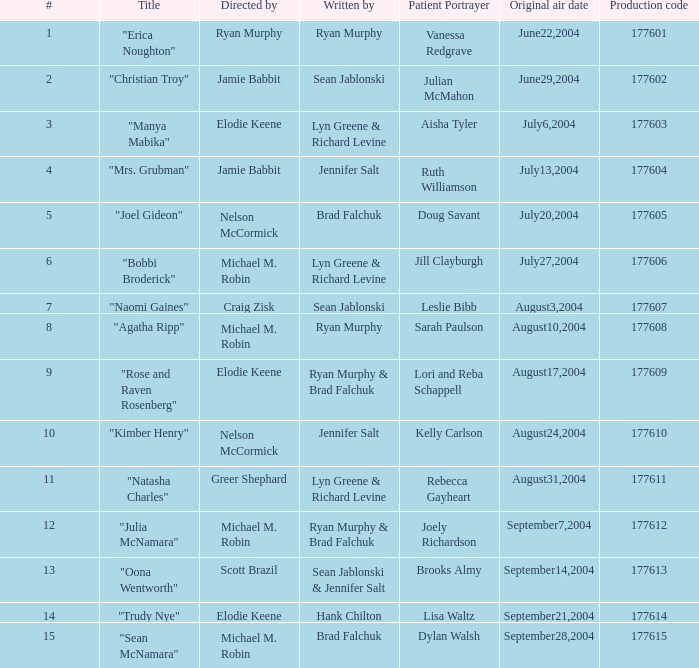Which episode number has the title "naomi gaines"? 20.0. 